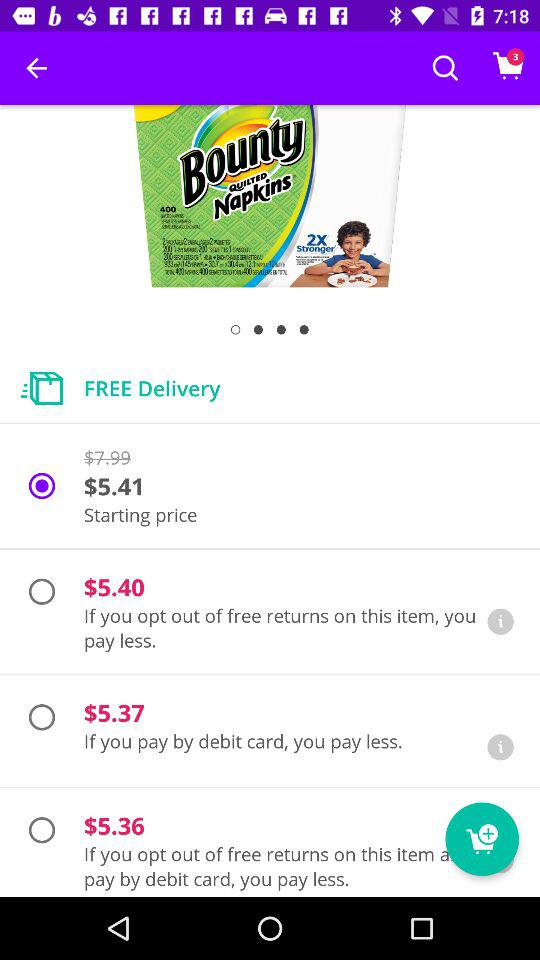How much do I save if I choose the lowest price option?
Answer the question using a single word or phrase. $2.63 